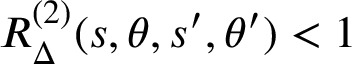<formula> <loc_0><loc_0><loc_500><loc_500>R _ { \Delta } ^ { ( 2 ) } ( s , \theta , s ^ { \prime } , \theta ^ { \prime } ) < 1</formula> 